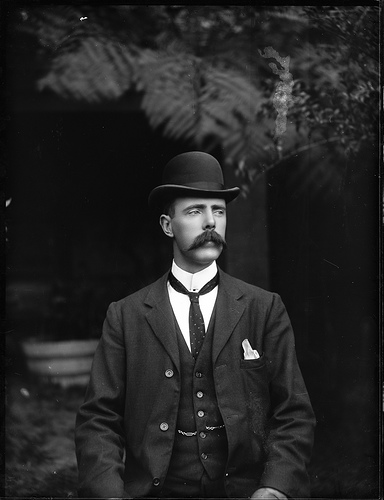<image>On which lapel is the gentleman wearing a flower? It is ambiguous on which lapel the gentleman is wearing a flower. It can be on left or none. On which lapel is the gentleman wearing a flower? The gentleman is not wearing a flower on either lapel. 